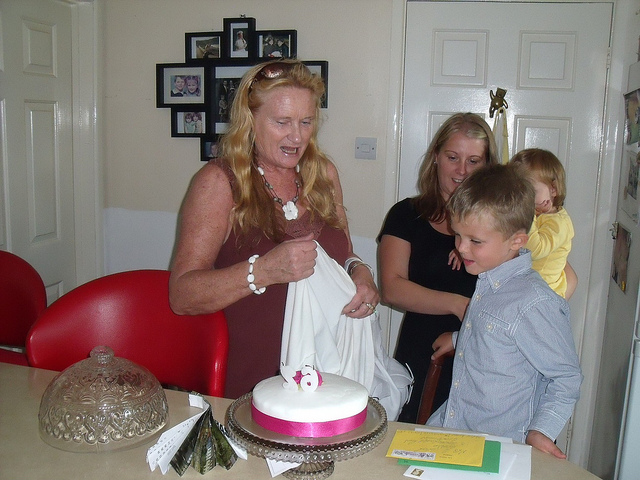Please transcribe the text information in this image. 62 